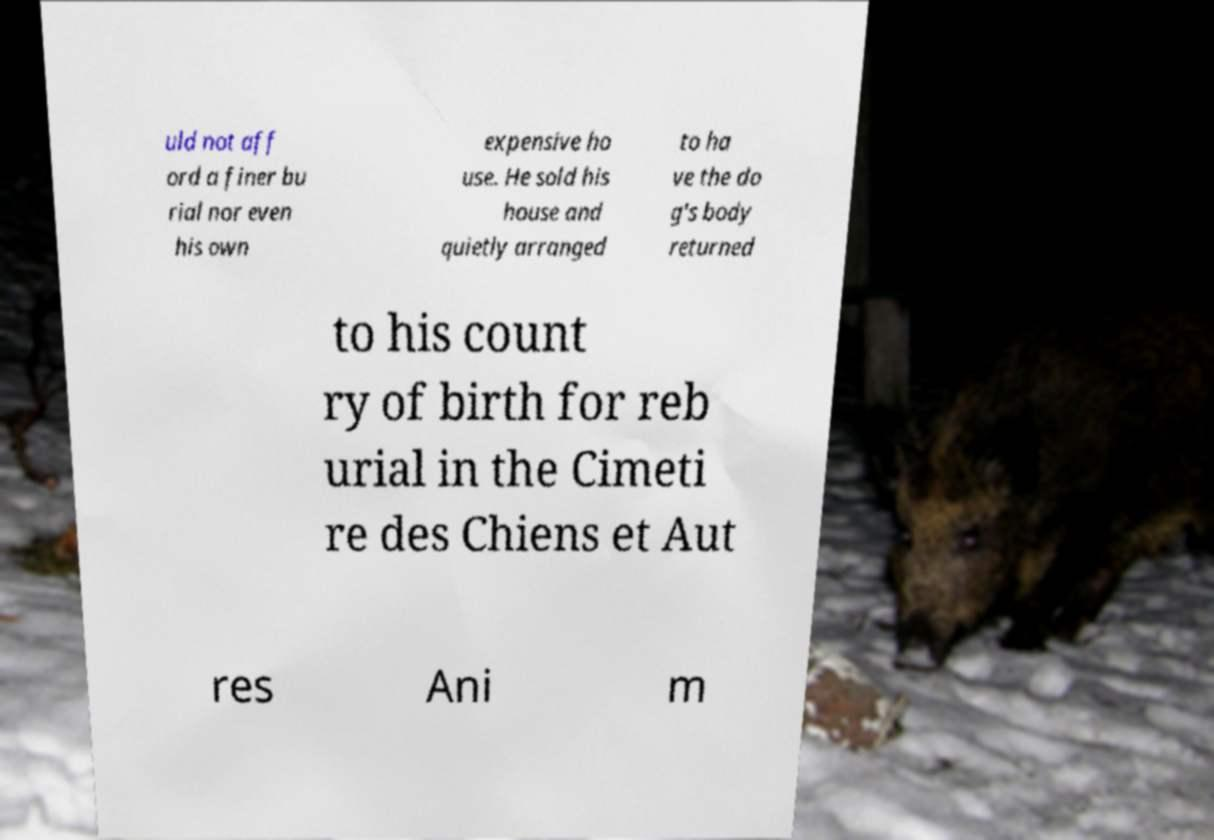Could you assist in decoding the text presented in this image and type it out clearly? uld not aff ord a finer bu rial nor even his own expensive ho use. He sold his house and quietly arranged to ha ve the do g's body returned to his count ry of birth for reb urial in the Cimeti re des Chiens et Aut res Ani m 